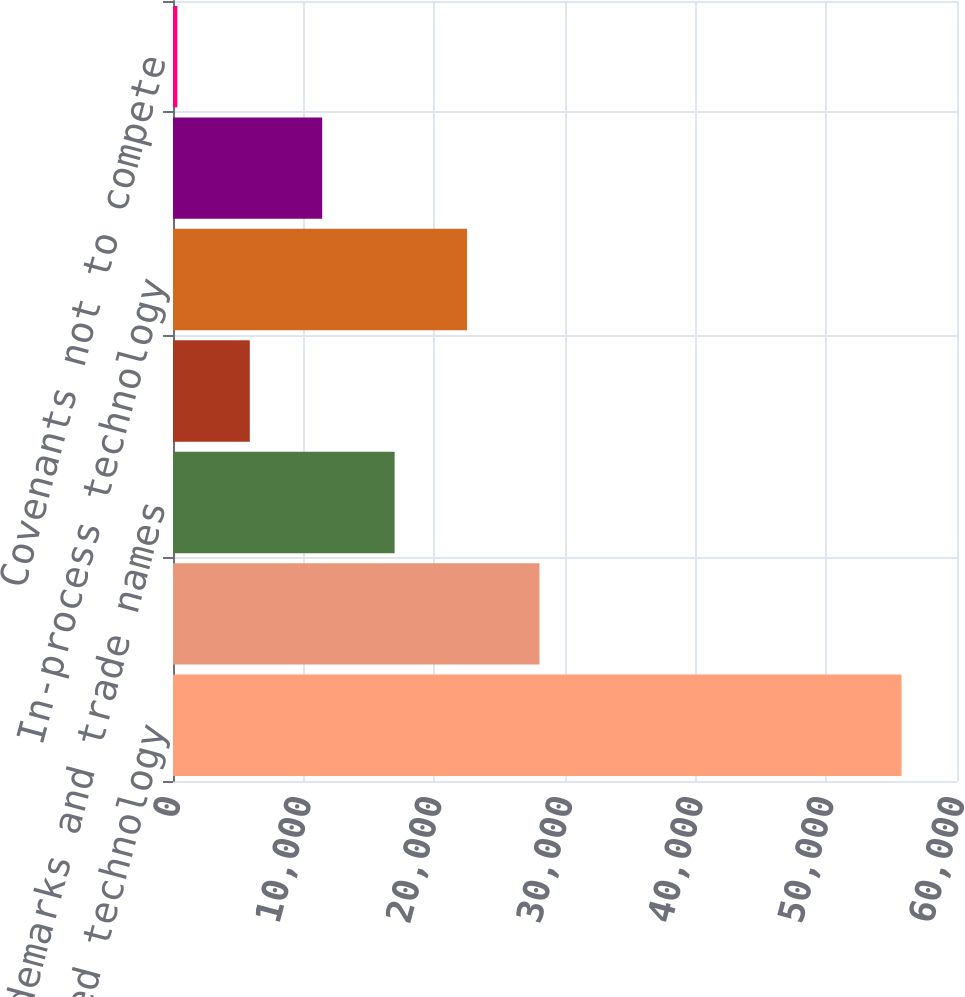Convert chart. <chart><loc_0><loc_0><loc_500><loc_500><bar_chart><fcel>Developed technology<fcel>Customer-related<fcel>Trademarks and trade names<fcel>Backlog<fcel>In-process technology<fcel>Distribution rights<fcel>Covenants not to compete<nl><fcel>55757<fcel>28045.5<fcel>16960.9<fcel>5876.3<fcel>22503.2<fcel>11418.6<fcel>334<nl></chart> 